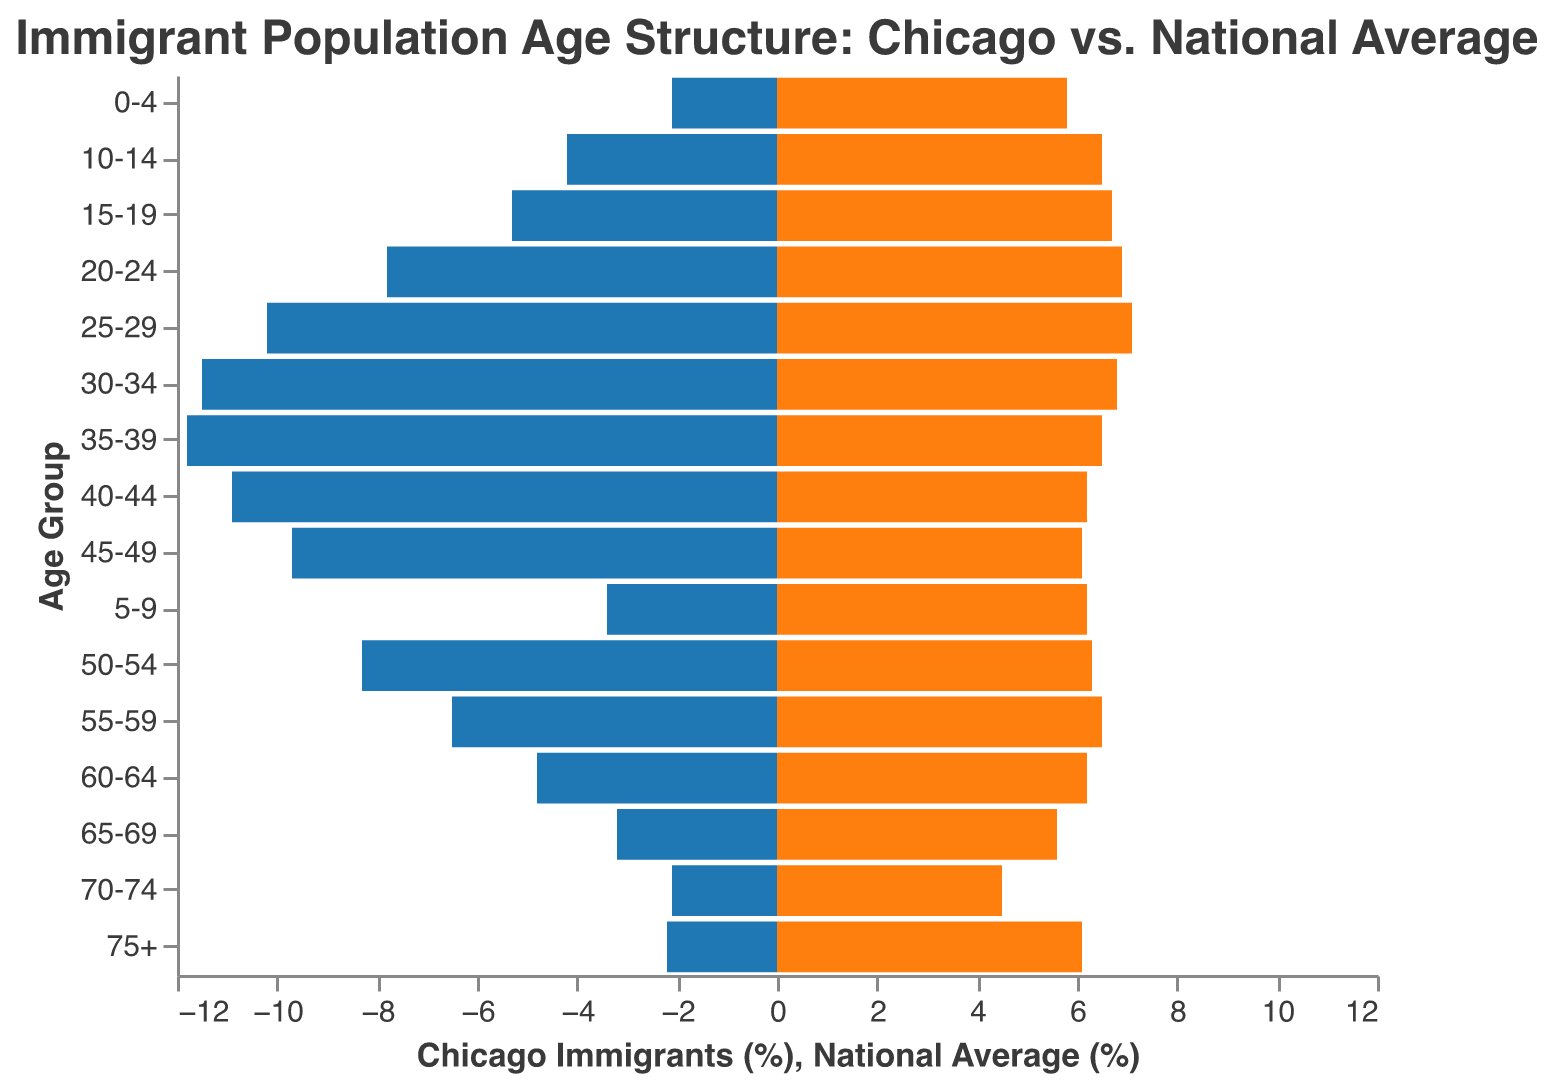Which age group has the highest percentage of Chicago immigrants? The figure shows the percentage of Chicago immigrants for each age group. By finding the highest value on the left side of the pyramid, we see that the 35-39 age group has the highest percentage.
Answer: 35-39 In which age group do the national average and Chicago immigrant percentages differ the most? To determine this, look for the age group with the largest visual difference between the bar lengths of the Chicago immigrants (%) and the national average (%). The 75+ age group shows the largest difference: 6.1% (national) vs. 2.2% (Chicago).
Answer: 75+ What is the total percentage of Chicago immigrants aged 0-19? Sum the percentages for the age groups 0-4, 5-9, 10-14, and 15-19. That's 2.1% + 3.4% + 4.2% + 5.3% = 15%.
Answer: 15% Which age group has a higher percentage in the national average than in Chicago immigrants? Compare each age group's percentage for the national average and Chicago immigrants. The age group 0-4 has a higher percentage in the national average (5.8%) than in Chicago immigrants (2.1%).
Answer: 0-4 Which age group has almost equal percentages of Chicago immigrants and the national average? Look for age groups where the bars of Chicago immigrants and the national average are of similar length. The age group 55-59 shows an equal percentage for both (6.5%).
Answer: 55-59 At what age group does the percentage of Chicago immigrants start to fall below 5%? Find the age group where the percentage for Chicago immigrants drops below 5% for the first time. This happens at the 60-64 age group.
Answer: 60-64 What is the average percentage of Chicago immigrants for the age groups 20-24 to 40-44? Calculate the average by summing the percentages for the age groups 20-24, 25-29, 30-34, 35-39, and 40-44 and then dividing by the number of groups: (7.8 + 10.2 + 11.5 + 11.8 + 10.9) / 5 = 52.2 / 5 = 10.44%.
Answer: 10.44% For which age group is the percentage difference between Chicago immigrants and the national average the smallest? Look for the age group where the difference in bar lengths for Chicago immigrants (%) and the national average (%) is the smallest. The age group 55-59 has the smallest difference (0.0%).
Answer: 55-59 What is the range of percentages for Chicago immigrants across all age groups? The range is found by subtracting the smallest percentage from the highest percentage of Chicago immigrants. The highest percentage is 11.8% (35-39 age group), and the smallest is 2.1% (0-4 and 70-74 age groups). So, 11.8% - 2.1% = 9.7%.
Answer: 9.7% 